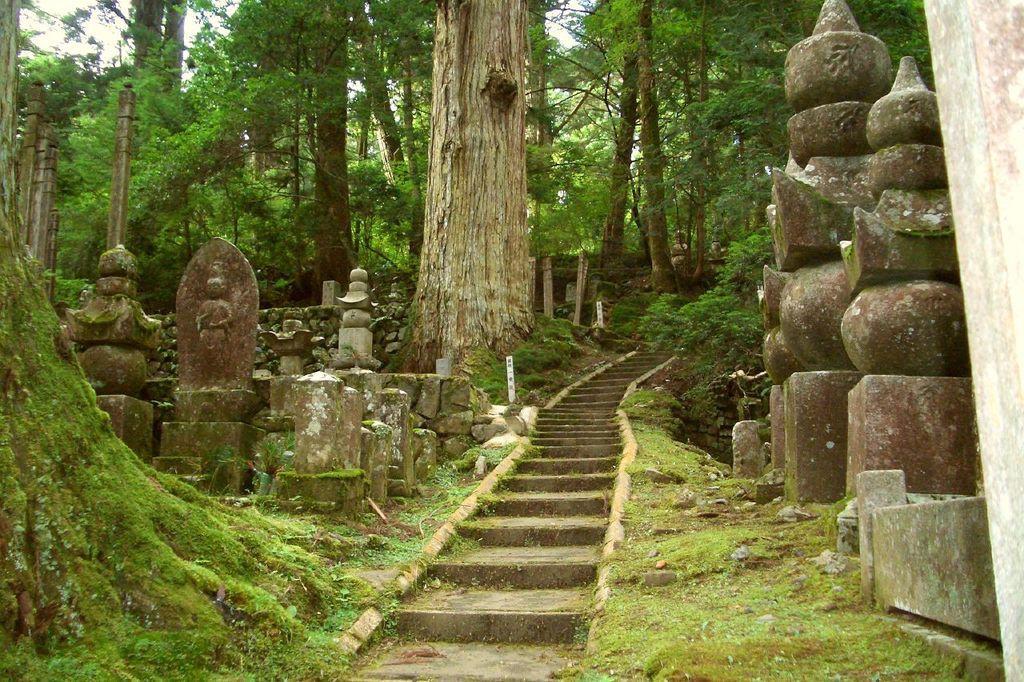Please provide a concise description of this image. On the right there are trees, sculptures and grass. In the center of the picture there are trees and staircase. On the left there are sculptures, trees and grass. 